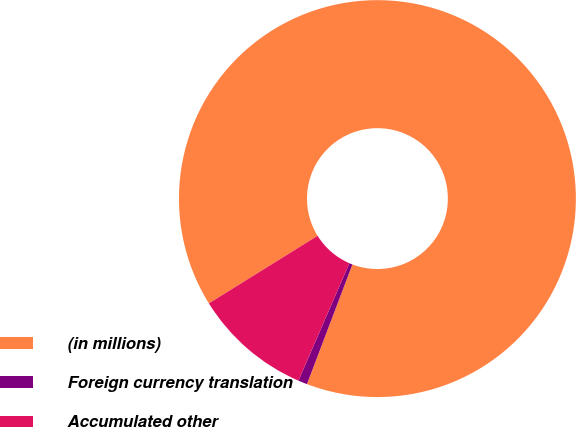Convert chart. <chart><loc_0><loc_0><loc_500><loc_500><pie_chart><fcel>(in millions)<fcel>Foreign currency translation<fcel>Accumulated other<nl><fcel>89.63%<fcel>0.74%<fcel>9.63%<nl></chart> 